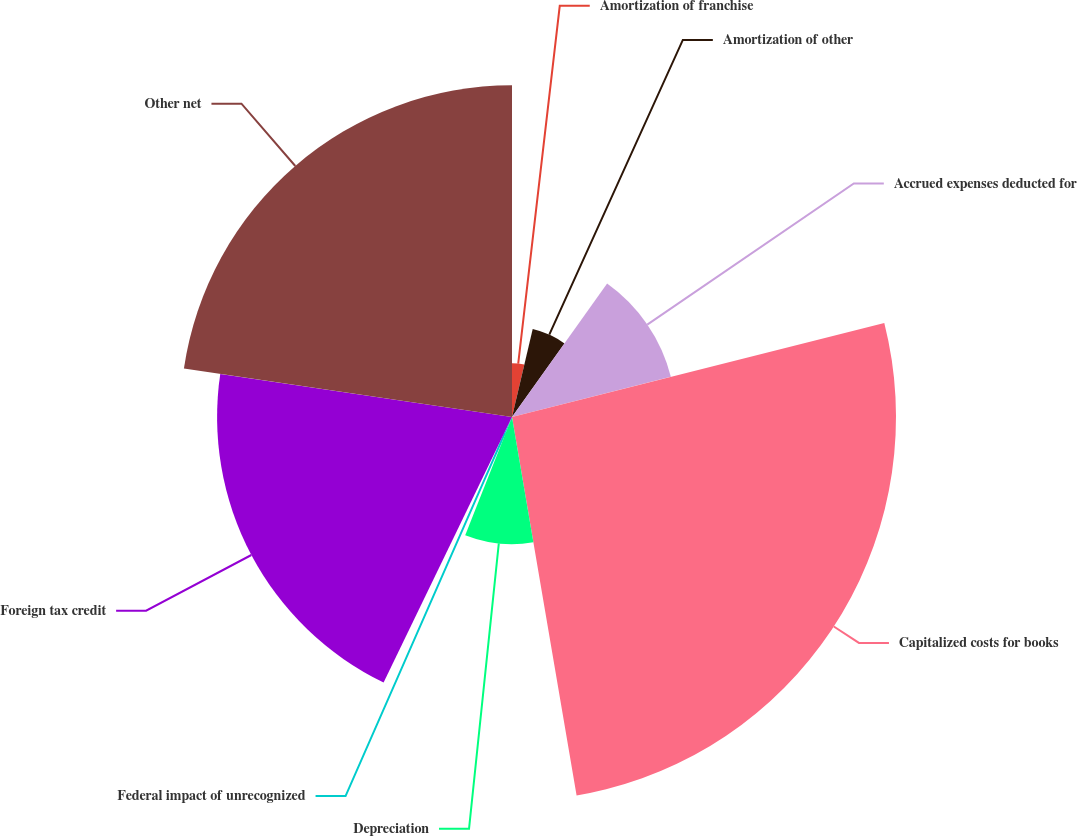<chart> <loc_0><loc_0><loc_500><loc_500><pie_chart><fcel>Amortization of franchise<fcel>Amortization of other<fcel>Accrued expenses deducted for<fcel>Capitalized costs for books<fcel>Depreciation<fcel>Federal impact of unrecognized<fcel>Foreign tax credit<fcel>Other net<nl><fcel>3.68%<fcel>6.18%<fcel>11.2%<fcel>26.25%<fcel>8.69%<fcel>1.17%<fcel>20.16%<fcel>22.67%<nl></chart> 